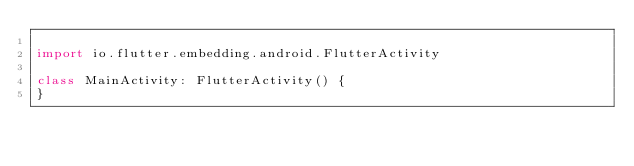Convert code to text. <code><loc_0><loc_0><loc_500><loc_500><_Kotlin_>
import io.flutter.embedding.android.FlutterActivity

class MainActivity: FlutterActivity() {
}
</code> 